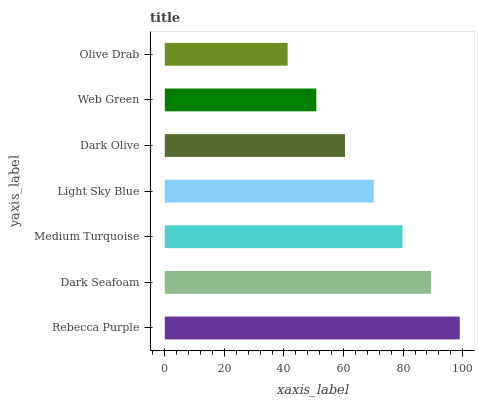Is Olive Drab the minimum?
Answer yes or no. Yes. Is Rebecca Purple the maximum?
Answer yes or no. Yes. Is Dark Seafoam the minimum?
Answer yes or no. No. Is Dark Seafoam the maximum?
Answer yes or no. No. Is Rebecca Purple greater than Dark Seafoam?
Answer yes or no. Yes. Is Dark Seafoam less than Rebecca Purple?
Answer yes or no. Yes. Is Dark Seafoam greater than Rebecca Purple?
Answer yes or no. No. Is Rebecca Purple less than Dark Seafoam?
Answer yes or no. No. Is Light Sky Blue the high median?
Answer yes or no. Yes. Is Light Sky Blue the low median?
Answer yes or no. Yes. Is Medium Turquoise the high median?
Answer yes or no. No. Is Olive Drab the low median?
Answer yes or no. No. 